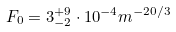Convert formula to latex. <formula><loc_0><loc_0><loc_500><loc_500>F _ { 0 } = 3 ^ { + 9 } _ { - 2 } \cdot 1 0 ^ { - 4 } m ^ { - 2 0 / 3 }</formula> 